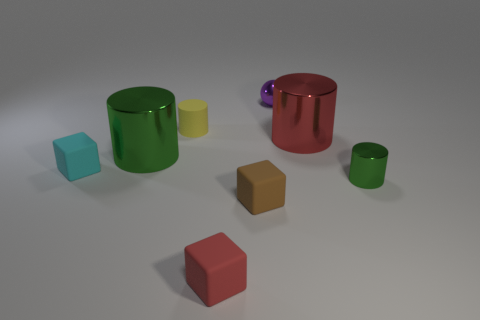How many green cylinders must be subtracted to get 1 green cylinders? 1 Add 1 yellow cylinders. How many objects exist? 9 Subtract all cubes. How many objects are left? 5 Subtract 2 cylinders. How many cylinders are left? 2 Subtract all gray balls. Subtract all cyan cubes. How many balls are left? 1 Subtract all blue balls. How many yellow cubes are left? 0 Subtract all brown rubber cubes. Subtract all large green metallic spheres. How many objects are left? 7 Add 5 red blocks. How many red blocks are left? 6 Add 2 big cyan rubber blocks. How many big cyan rubber blocks exist? 2 Subtract all red cylinders. How many cylinders are left? 3 